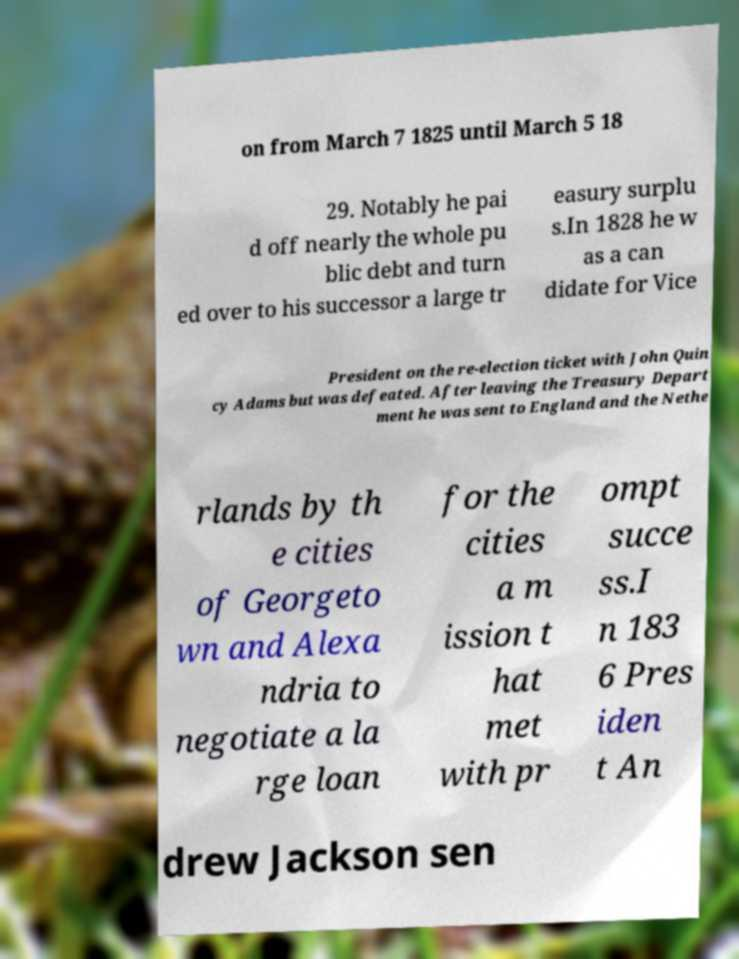Could you assist in decoding the text presented in this image and type it out clearly? on from March 7 1825 until March 5 18 29. Notably he pai d off nearly the whole pu blic debt and turn ed over to his successor a large tr easury surplu s.In 1828 he w as a can didate for Vice President on the re-election ticket with John Quin cy Adams but was defeated. After leaving the Treasury Depart ment he was sent to England and the Nethe rlands by th e cities of Georgeto wn and Alexa ndria to negotiate a la rge loan for the cities a m ission t hat met with pr ompt succe ss.I n 183 6 Pres iden t An drew Jackson sen 